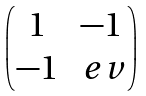<formula> <loc_0><loc_0><loc_500><loc_500>\begin{pmatrix} 1 & - 1 \\ - 1 & \ e v \end{pmatrix}</formula> 